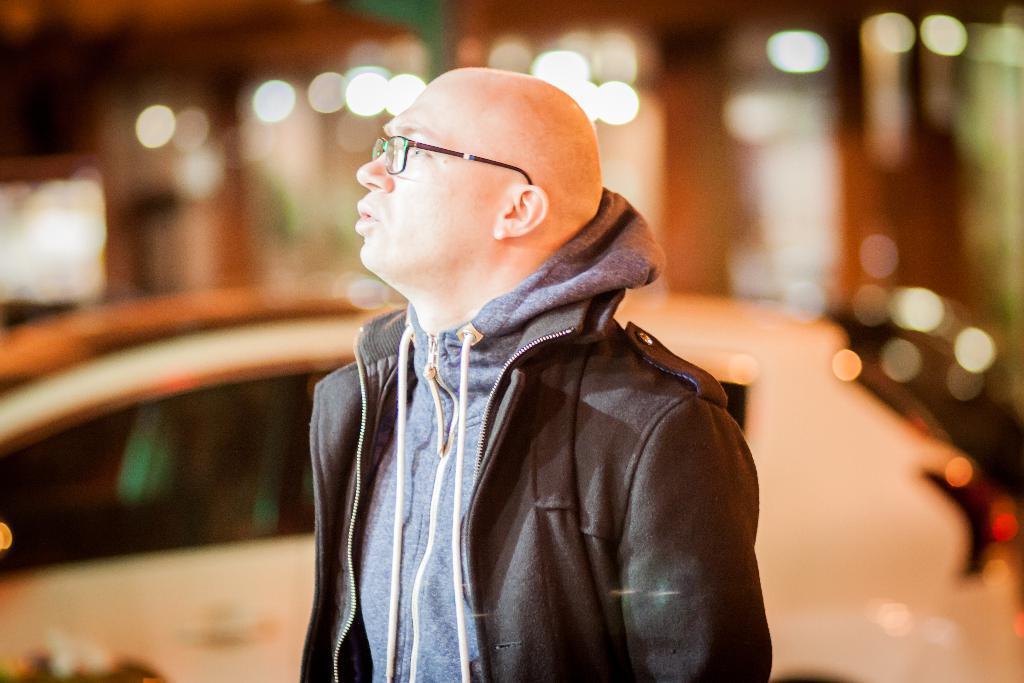In one or two sentences, can you explain what this image depicts? In this picture we can see a man wearing black jacket, standing in front and looking on the left side. Behind we can see the white color car is parked and blur image in the background. 